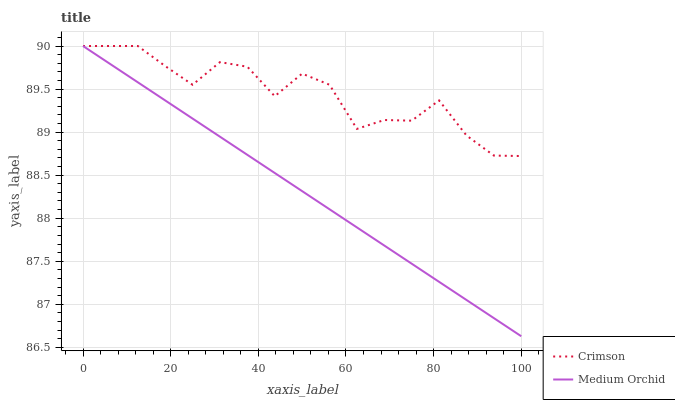Does Medium Orchid have the minimum area under the curve?
Answer yes or no. Yes. Does Crimson have the maximum area under the curve?
Answer yes or no. Yes. Does Medium Orchid have the maximum area under the curve?
Answer yes or no. No. Is Medium Orchid the smoothest?
Answer yes or no. Yes. Is Crimson the roughest?
Answer yes or no. Yes. Is Medium Orchid the roughest?
Answer yes or no. No. Does Medium Orchid have the lowest value?
Answer yes or no. Yes. Does Medium Orchid have the highest value?
Answer yes or no. Yes. Does Medium Orchid intersect Crimson?
Answer yes or no. Yes. Is Medium Orchid less than Crimson?
Answer yes or no. No. Is Medium Orchid greater than Crimson?
Answer yes or no. No. 